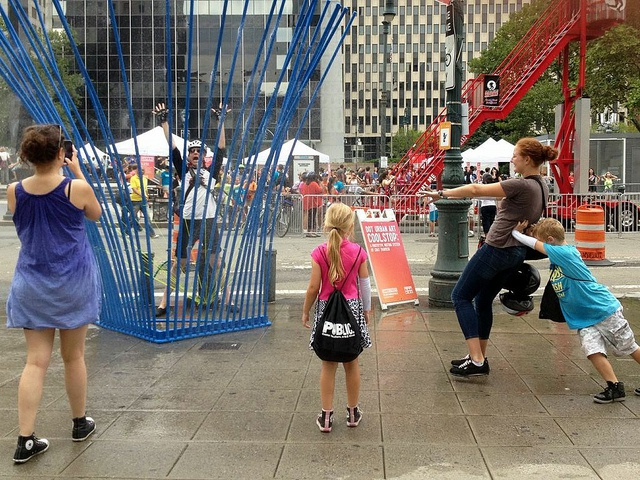Describe the objects in this image and their specific colors. I can see people in lightgray, gray, navy, black, and tan tones, people in lightgray, black, gray, and maroon tones, people in lightgray, black, gray, brown, and tan tones, people in lightgray, teal, and darkgray tones, and people in lightgray, gray, black, and blue tones in this image. 